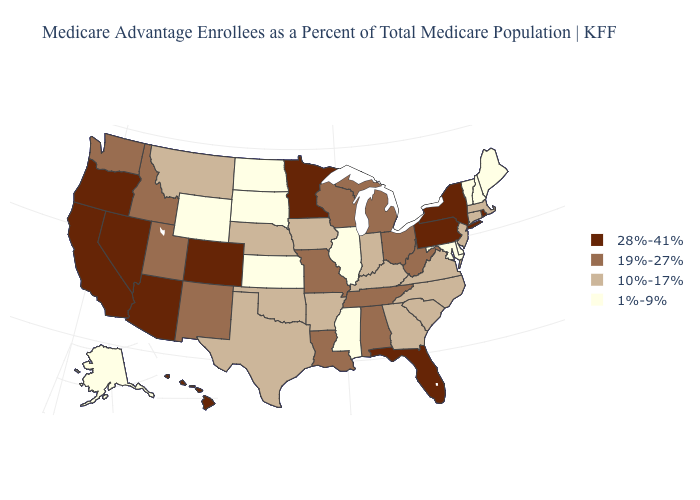Among the states that border Montana , does North Dakota have the lowest value?
Keep it brief. Yes. Is the legend a continuous bar?
Write a very short answer. No. What is the lowest value in the South?
Write a very short answer. 1%-9%. Among the states that border Alabama , which have the highest value?
Concise answer only. Florida. What is the value of Indiana?
Concise answer only. 10%-17%. Which states have the highest value in the USA?
Be succinct. Arizona, California, Colorado, Florida, Hawaii, Minnesota, Nevada, New York, Oregon, Pennsylvania, Rhode Island. What is the value of Maine?
Give a very brief answer. 1%-9%. Name the states that have a value in the range 10%-17%?
Short answer required. Arkansas, Connecticut, Georgia, Iowa, Indiana, Kentucky, Massachusetts, Montana, North Carolina, Nebraska, New Jersey, Oklahoma, South Carolina, Texas, Virginia. What is the value of Iowa?
Be succinct. 10%-17%. Is the legend a continuous bar?
Give a very brief answer. No. What is the highest value in the South ?
Answer briefly. 28%-41%. Is the legend a continuous bar?
Keep it brief. No. What is the value of Florida?
Quick response, please. 28%-41%. Does the first symbol in the legend represent the smallest category?
Short answer required. No. What is the lowest value in states that border Mississippi?
Concise answer only. 10%-17%. 